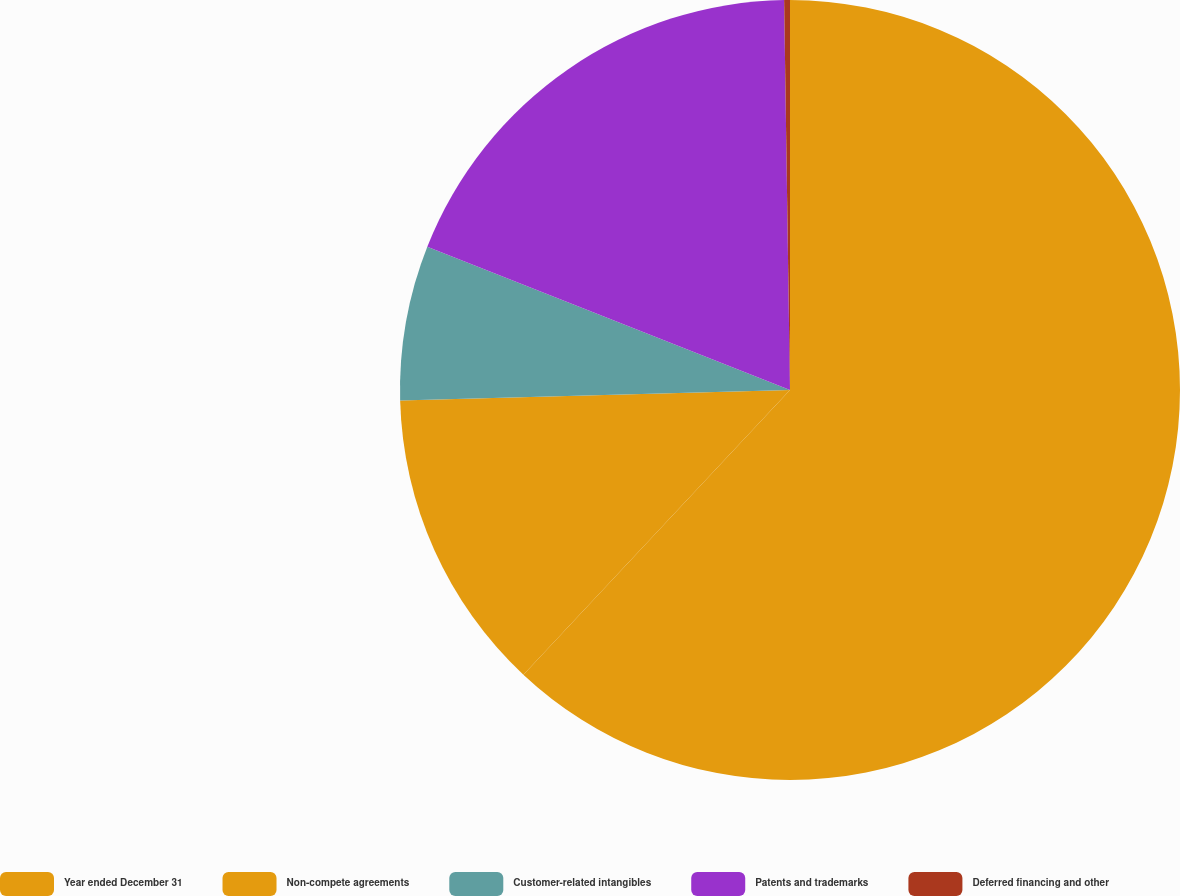Convert chart. <chart><loc_0><loc_0><loc_500><loc_500><pie_chart><fcel>Year ended December 31<fcel>Non-compete agreements<fcel>Customer-related intangibles<fcel>Patents and trademarks<fcel>Deferred financing and other<nl><fcel>61.98%<fcel>12.59%<fcel>6.42%<fcel>18.77%<fcel>0.24%<nl></chart> 